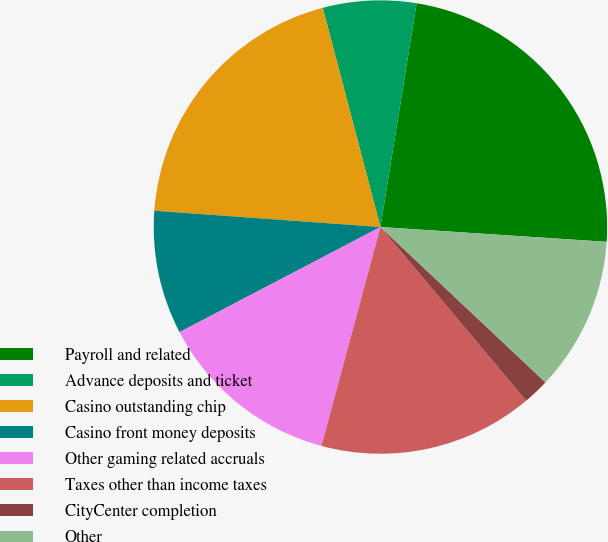Convert chart to OTSL. <chart><loc_0><loc_0><loc_500><loc_500><pie_chart><fcel>Payroll and related<fcel>Advance deposits and ticket<fcel>Casino outstanding chip<fcel>Casino front money deposits<fcel>Other gaming related accruals<fcel>Taxes other than income taxes<fcel>CityCenter completion<fcel>Other<nl><fcel>23.49%<fcel>6.65%<fcel>19.76%<fcel>8.82%<fcel>13.14%<fcel>15.3%<fcel>1.87%<fcel>10.98%<nl></chart> 